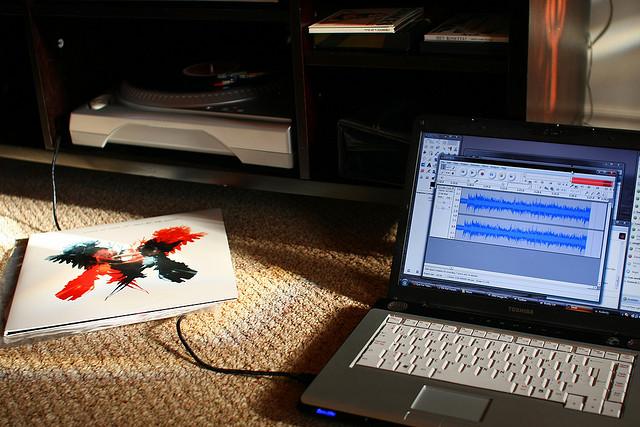Is there a snake in the photo?
Answer briefly. No. What colors are the ribbons on the keyboard of the laptop?
Concise answer only. White. Is the computer turned off?
Keep it brief. No. Where is the laptop?
Be succinct. On floor. 